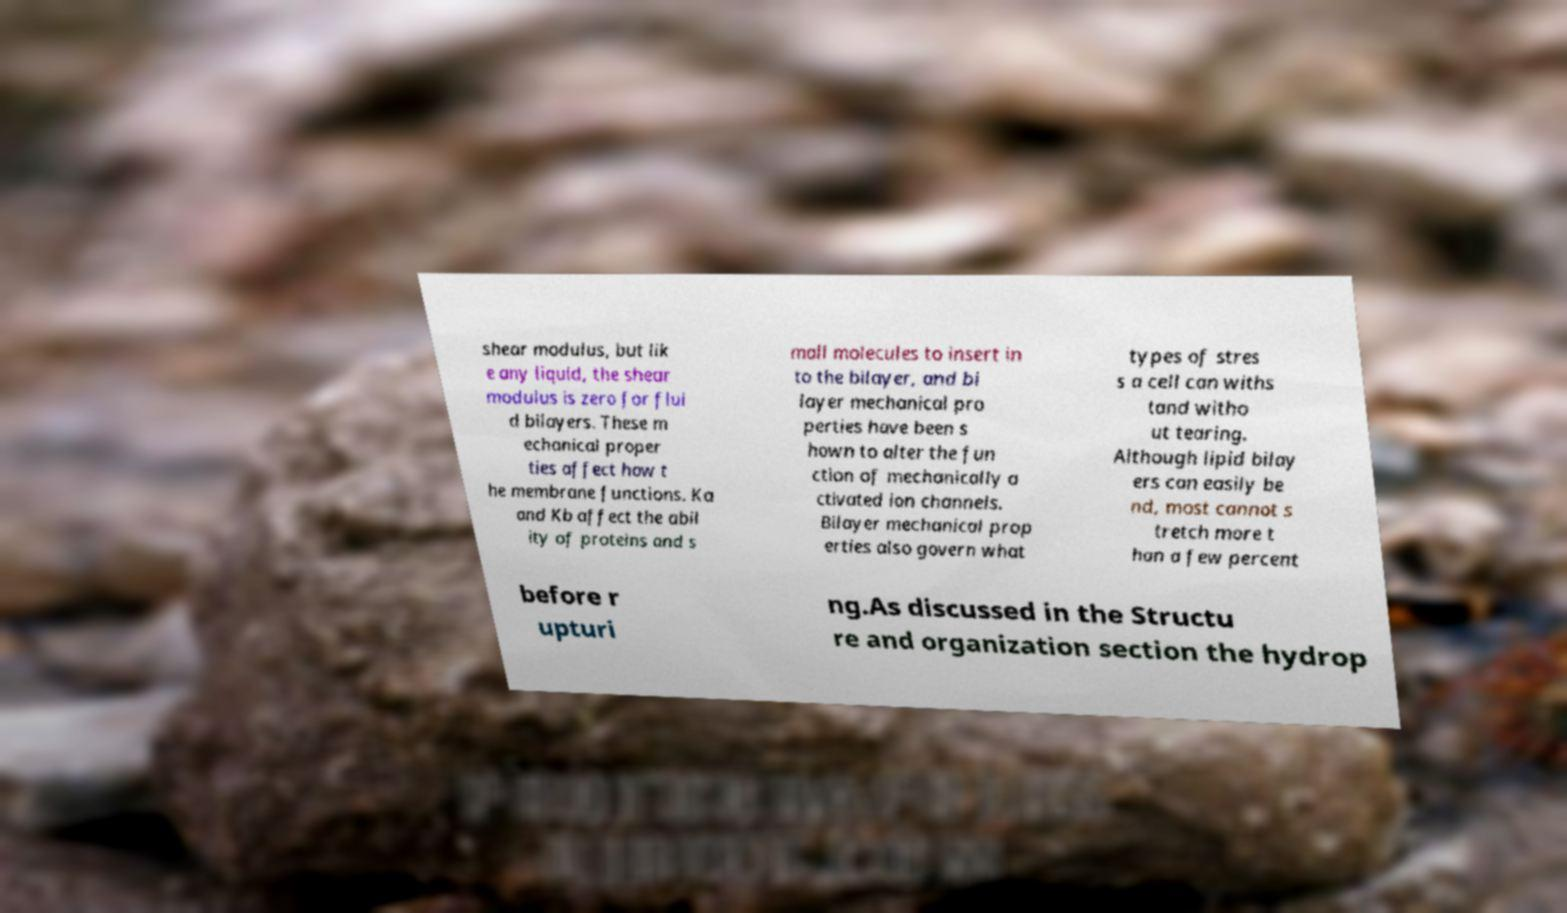What messages or text are displayed in this image? I need them in a readable, typed format. shear modulus, but lik e any liquid, the shear modulus is zero for flui d bilayers. These m echanical proper ties affect how t he membrane functions. Ka and Kb affect the abil ity of proteins and s mall molecules to insert in to the bilayer, and bi layer mechanical pro perties have been s hown to alter the fun ction of mechanically a ctivated ion channels. Bilayer mechanical prop erties also govern what types of stres s a cell can withs tand witho ut tearing. Although lipid bilay ers can easily be nd, most cannot s tretch more t han a few percent before r upturi ng.As discussed in the Structu re and organization section the hydrop 